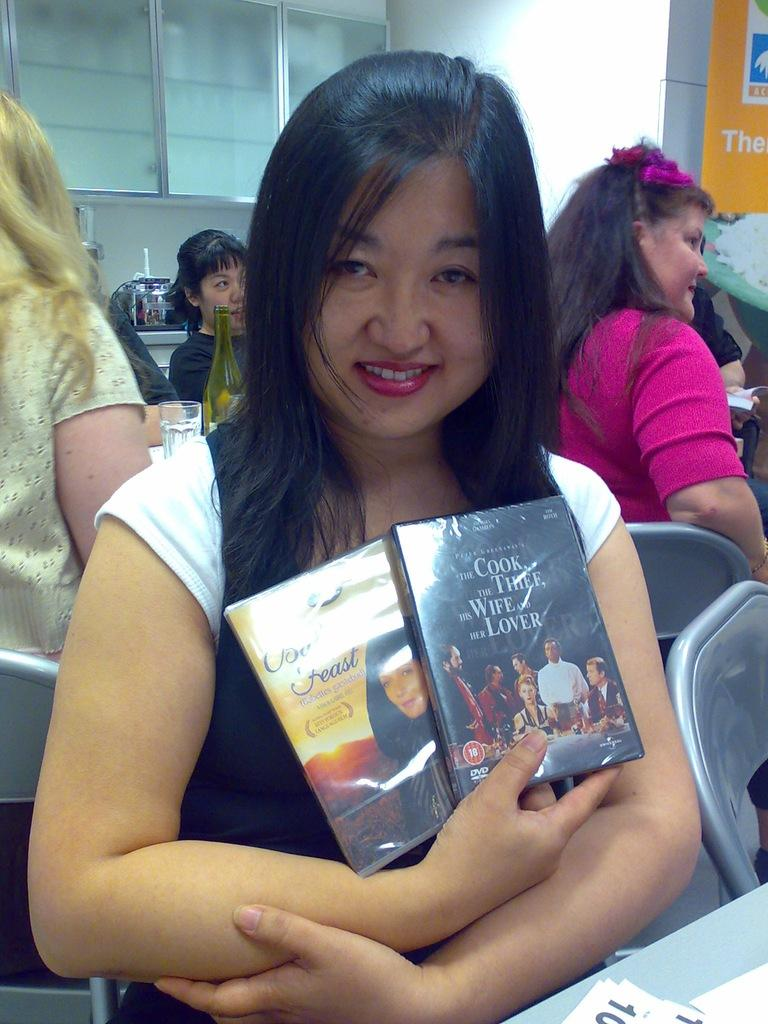Who is the main subject in the image? There is a woman in the image. What is the woman doing in the image? The woman is sitting in a chair and holding two books in her hand. What else can be seen in the image? There is a table in the image, and other women are sitting in the background. What type of yoke is the woman using to read the books in the image? There is no yoke present in the image, and the woman is not using any device to read the books. 